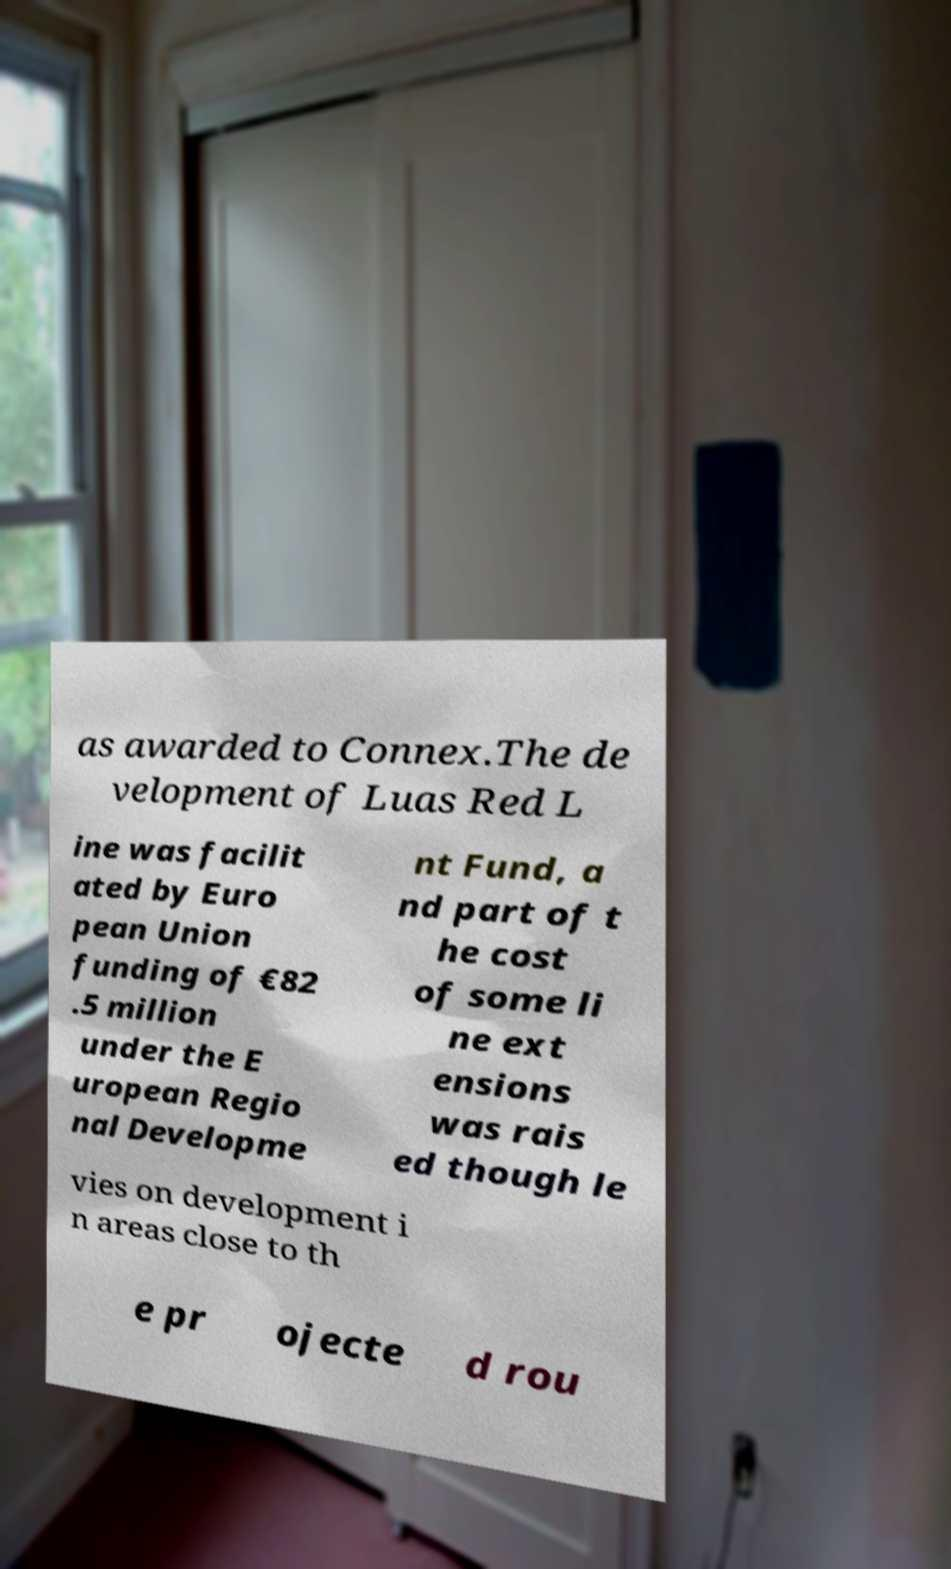Can you read and provide the text displayed in the image?This photo seems to have some interesting text. Can you extract and type it out for me? as awarded to Connex.The de velopment of Luas Red L ine was facilit ated by Euro pean Union funding of €82 .5 million under the E uropean Regio nal Developme nt Fund, a nd part of t he cost of some li ne ext ensions was rais ed though le vies on development i n areas close to th e pr ojecte d rou 